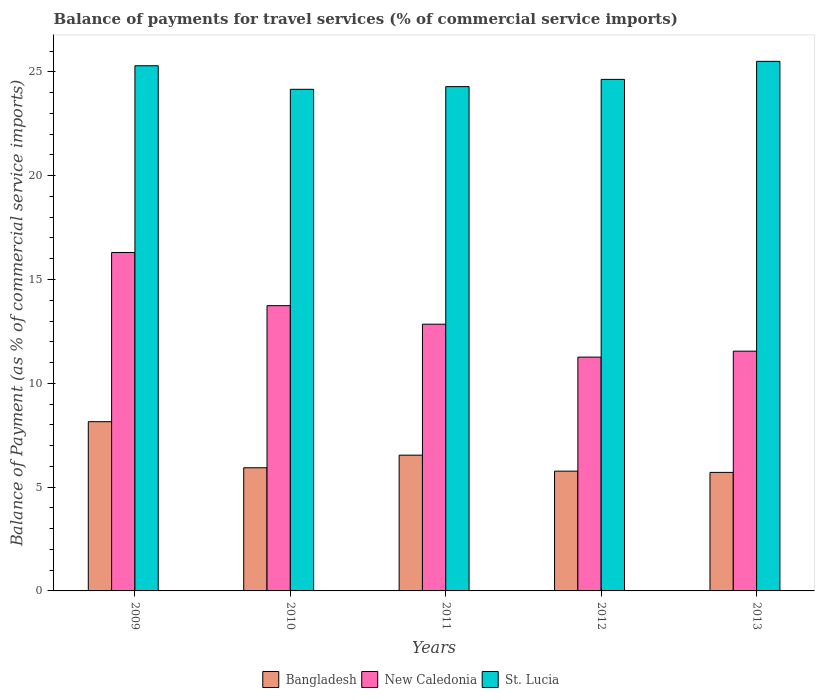Are the number of bars per tick equal to the number of legend labels?
Make the answer very short. Yes. Are the number of bars on each tick of the X-axis equal?
Provide a short and direct response. Yes. How many bars are there on the 4th tick from the right?
Provide a short and direct response. 3. What is the label of the 3rd group of bars from the left?
Provide a succinct answer. 2011. In how many cases, is the number of bars for a given year not equal to the number of legend labels?
Ensure brevity in your answer.  0. What is the balance of payments for travel services in St. Lucia in 2012?
Provide a short and direct response. 24.64. Across all years, what is the maximum balance of payments for travel services in New Caledonia?
Offer a very short reply. 16.3. Across all years, what is the minimum balance of payments for travel services in Bangladesh?
Provide a succinct answer. 5.71. In which year was the balance of payments for travel services in St. Lucia minimum?
Provide a succinct answer. 2010. What is the total balance of payments for travel services in New Caledonia in the graph?
Offer a terse response. 65.69. What is the difference between the balance of payments for travel services in New Caledonia in 2012 and that in 2013?
Keep it short and to the point. -0.29. What is the difference between the balance of payments for travel services in St. Lucia in 2011 and the balance of payments for travel services in New Caledonia in 2010?
Your response must be concise. 10.55. What is the average balance of payments for travel services in New Caledonia per year?
Give a very brief answer. 13.14. In the year 2012, what is the difference between the balance of payments for travel services in St. Lucia and balance of payments for travel services in Bangladesh?
Give a very brief answer. 18.87. What is the ratio of the balance of payments for travel services in New Caledonia in 2009 to that in 2012?
Keep it short and to the point. 1.45. What is the difference between the highest and the second highest balance of payments for travel services in New Caledonia?
Your answer should be very brief. 2.56. What is the difference between the highest and the lowest balance of payments for travel services in St. Lucia?
Provide a succinct answer. 1.35. In how many years, is the balance of payments for travel services in St. Lucia greater than the average balance of payments for travel services in St. Lucia taken over all years?
Your response must be concise. 2. Is the sum of the balance of payments for travel services in New Caledonia in 2010 and 2012 greater than the maximum balance of payments for travel services in Bangladesh across all years?
Provide a short and direct response. Yes. What does the 3rd bar from the left in 2012 represents?
Offer a terse response. St. Lucia. What does the 1st bar from the right in 2010 represents?
Provide a short and direct response. St. Lucia. How many bars are there?
Your answer should be compact. 15. What is the difference between two consecutive major ticks on the Y-axis?
Provide a short and direct response. 5. Are the values on the major ticks of Y-axis written in scientific E-notation?
Your answer should be very brief. No. Does the graph contain any zero values?
Provide a succinct answer. No. Does the graph contain grids?
Offer a terse response. No. How many legend labels are there?
Offer a very short reply. 3. How are the legend labels stacked?
Provide a short and direct response. Horizontal. What is the title of the graph?
Keep it short and to the point. Balance of payments for travel services (% of commercial service imports). What is the label or title of the X-axis?
Offer a terse response. Years. What is the label or title of the Y-axis?
Keep it short and to the point. Balance of Payment (as % of commercial service imports). What is the Balance of Payment (as % of commercial service imports) in Bangladesh in 2009?
Your answer should be very brief. 8.15. What is the Balance of Payment (as % of commercial service imports) in New Caledonia in 2009?
Your response must be concise. 16.3. What is the Balance of Payment (as % of commercial service imports) of St. Lucia in 2009?
Your response must be concise. 25.29. What is the Balance of Payment (as % of commercial service imports) of Bangladesh in 2010?
Provide a succinct answer. 5.93. What is the Balance of Payment (as % of commercial service imports) in New Caledonia in 2010?
Give a very brief answer. 13.74. What is the Balance of Payment (as % of commercial service imports) in St. Lucia in 2010?
Your answer should be compact. 24.16. What is the Balance of Payment (as % of commercial service imports) of Bangladesh in 2011?
Your response must be concise. 6.54. What is the Balance of Payment (as % of commercial service imports) in New Caledonia in 2011?
Your answer should be very brief. 12.85. What is the Balance of Payment (as % of commercial service imports) in St. Lucia in 2011?
Ensure brevity in your answer.  24.29. What is the Balance of Payment (as % of commercial service imports) of Bangladesh in 2012?
Give a very brief answer. 5.77. What is the Balance of Payment (as % of commercial service imports) of New Caledonia in 2012?
Provide a short and direct response. 11.26. What is the Balance of Payment (as % of commercial service imports) of St. Lucia in 2012?
Provide a succinct answer. 24.64. What is the Balance of Payment (as % of commercial service imports) in Bangladesh in 2013?
Ensure brevity in your answer.  5.71. What is the Balance of Payment (as % of commercial service imports) of New Caledonia in 2013?
Your answer should be very brief. 11.55. What is the Balance of Payment (as % of commercial service imports) in St. Lucia in 2013?
Provide a short and direct response. 25.51. Across all years, what is the maximum Balance of Payment (as % of commercial service imports) of Bangladesh?
Offer a terse response. 8.15. Across all years, what is the maximum Balance of Payment (as % of commercial service imports) in New Caledonia?
Your answer should be very brief. 16.3. Across all years, what is the maximum Balance of Payment (as % of commercial service imports) of St. Lucia?
Make the answer very short. 25.51. Across all years, what is the minimum Balance of Payment (as % of commercial service imports) of Bangladesh?
Your answer should be very brief. 5.71. Across all years, what is the minimum Balance of Payment (as % of commercial service imports) of New Caledonia?
Make the answer very short. 11.26. Across all years, what is the minimum Balance of Payment (as % of commercial service imports) in St. Lucia?
Ensure brevity in your answer.  24.16. What is the total Balance of Payment (as % of commercial service imports) of Bangladesh in the graph?
Give a very brief answer. 32.1. What is the total Balance of Payment (as % of commercial service imports) in New Caledonia in the graph?
Your answer should be very brief. 65.69. What is the total Balance of Payment (as % of commercial service imports) in St. Lucia in the graph?
Your answer should be compact. 123.89. What is the difference between the Balance of Payment (as % of commercial service imports) of Bangladesh in 2009 and that in 2010?
Offer a terse response. 2.22. What is the difference between the Balance of Payment (as % of commercial service imports) of New Caledonia in 2009 and that in 2010?
Make the answer very short. 2.56. What is the difference between the Balance of Payment (as % of commercial service imports) of St. Lucia in 2009 and that in 2010?
Offer a terse response. 1.14. What is the difference between the Balance of Payment (as % of commercial service imports) of Bangladesh in 2009 and that in 2011?
Give a very brief answer. 1.61. What is the difference between the Balance of Payment (as % of commercial service imports) of New Caledonia in 2009 and that in 2011?
Keep it short and to the point. 3.45. What is the difference between the Balance of Payment (as % of commercial service imports) of Bangladesh in 2009 and that in 2012?
Your response must be concise. 2.38. What is the difference between the Balance of Payment (as % of commercial service imports) of New Caledonia in 2009 and that in 2012?
Offer a very short reply. 5.04. What is the difference between the Balance of Payment (as % of commercial service imports) of St. Lucia in 2009 and that in 2012?
Offer a very short reply. 0.66. What is the difference between the Balance of Payment (as % of commercial service imports) in Bangladesh in 2009 and that in 2013?
Offer a very short reply. 2.44. What is the difference between the Balance of Payment (as % of commercial service imports) of New Caledonia in 2009 and that in 2013?
Make the answer very short. 4.75. What is the difference between the Balance of Payment (as % of commercial service imports) of St. Lucia in 2009 and that in 2013?
Give a very brief answer. -0.21. What is the difference between the Balance of Payment (as % of commercial service imports) of Bangladesh in 2010 and that in 2011?
Provide a short and direct response. -0.61. What is the difference between the Balance of Payment (as % of commercial service imports) in New Caledonia in 2010 and that in 2011?
Your answer should be compact. 0.89. What is the difference between the Balance of Payment (as % of commercial service imports) in St. Lucia in 2010 and that in 2011?
Your answer should be compact. -0.13. What is the difference between the Balance of Payment (as % of commercial service imports) in Bangladesh in 2010 and that in 2012?
Ensure brevity in your answer.  0.16. What is the difference between the Balance of Payment (as % of commercial service imports) of New Caledonia in 2010 and that in 2012?
Give a very brief answer. 2.48. What is the difference between the Balance of Payment (as % of commercial service imports) in St. Lucia in 2010 and that in 2012?
Make the answer very short. -0.48. What is the difference between the Balance of Payment (as % of commercial service imports) of Bangladesh in 2010 and that in 2013?
Give a very brief answer. 0.22. What is the difference between the Balance of Payment (as % of commercial service imports) in New Caledonia in 2010 and that in 2013?
Offer a terse response. 2.19. What is the difference between the Balance of Payment (as % of commercial service imports) of St. Lucia in 2010 and that in 2013?
Offer a terse response. -1.35. What is the difference between the Balance of Payment (as % of commercial service imports) of Bangladesh in 2011 and that in 2012?
Provide a short and direct response. 0.77. What is the difference between the Balance of Payment (as % of commercial service imports) in New Caledonia in 2011 and that in 2012?
Your answer should be very brief. 1.59. What is the difference between the Balance of Payment (as % of commercial service imports) in St. Lucia in 2011 and that in 2012?
Provide a succinct answer. -0.35. What is the difference between the Balance of Payment (as % of commercial service imports) of Bangladesh in 2011 and that in 2013?
Provide a short and direct response. 0.83. What is the difference between the Balance of Payment (as % of commercial service imports) of New Caledonia in 2011 and that in 2013?
Your answer should be very brief. 1.3. What is the difference between the Balance of Payment (as % of commercial service imports) of St. Lucia in 2011 and that in 2013?
Provide a short and direct response. -1.22. What is the difference between the Balance of Payment (as % of commercial service imports) of Bangladesh in 2012 and that in 2013?
Offer a terse response. 0.06. What is the difference between the Balance of Payment (as % of commercial service imports) in New Caledonia in 2012 and that in 2013?
Provide a succinct answer. -0.29. What is the difference between the Balance of Payment (as % of commercial service imports) of St. Lucia in 2012 and that in 2013?
Offer a terse response. -0.87. What is the difference between the Balance of Payment (as % of commercial service imports) in Bangladesh in 2009 and the Balance of Payment (as % of commercial service imports) in New Caledonia in 2010?
Provide a short and direct response. -5.59. What is the difference between the Balance of Payment (as % of commercial service imports) in Bangladesh in 2009 and the Balance of Payment (as % of commercial service imports) in St. Lucia in 2010?
Offer a very short reply. -16.01. What is the difference between the Balance of Payment (as % of commercial service imports) of New Caledonia in 2009 and the Balance of Payment (as % of commercial service imports) of St. Lucia in 2010?
Your answer should be very brief. -7.86. What is the difference between the Balance of Payment (as % of commercial service imports) of Bangladesh in 2009 and the Balance of Payment (as % of commercial service imports) of New Caledonia in 2011?
Your answer should be compact. -4.7. What is the difference between the Balance of Payment (as % of commercial service imports) of Bangladesh in 2009 and the Balance of Payment (as % of commercial service imports) of St. Lucia in 2011?
Give a very brief answer. -16.14. What is the difference between the Balance of Payment (as % of commercial service imports) of New Caledonia in 2009 and the Balance of Payment (as % of commercial service imports) of St. Lucia in 2011?
Your answer should be compact. -7.99. What is the difference between the Balance of Payment (as % of commercial service imports) in Bangladesh in 2009 and the Balance of Payment (as % of commercial service imports) in New Caledonia in 2012?
Keep it short and to the point. -3.11. What is the difference between the Balance of Payment (as % of commercial service imports) of Bangladesh in 2009 and the Balance of Payment (as % of commercial service imports) of St. Lucia in 2012?
Provide a succinct answer. -16.49. What is the difference between the Balance of Payment (as % of commercial service imports) of New Caledonia in 2009 and the Balance of Payment (as % of commercial service imports) of St. Lucia in 2012?
Provide a succinct answer. -8.34. What is the difference between the Balance of Payment (as % of commercial service imports) in Bangladesh in 2009 and the Balance of Payment (as % of commercial service imports) in New Caledonia in 2013?
Give a very brief answer. -3.4. What is the difference between the Balance of Payment (as % of commercial service imports) of Bangladesh in 2009 and the Balance of Payment (as % of commercial service imports) of St. Lucia in 2013?
Offer a very short reply. -17.35. What is the difference between the Balance of Payment (as % of commercial service imports) in New Caledonia in 2009 and the Balance of Payment (as % of commercial service imports) in St. Lucia in 2013?
Your answer should be compact. -9.21. What is the difference between the Balance of Payment (as % of commercial service imports) of Bangladesh in 2010 and the Balance of Payment (as % of commercial service imports) of New Caledonia in 2011?
Offer a very short reply. -6.91. What is the difference between the Balance of Payment (as % of commercial service imports) in Bangladesh in 2010 and the Balance of Payment (as % of commercial service imports) in St. Lucia in 2011?
Offer a very short reply. -18.36. What is the difference between the Balance of Payment (as % of commercial service imports) of New Caledonia in 2010 and the Balance of Payment (as % of commercial service imports) of St. Lucia in 2011?
Your answer should be compact. -10.55. What is the difference between the Balance of Payment (as % of commercial service imports) in Bangladesh in 2010 and the Balance of Payment (as % of commercial service imports) in New Caledonia in 2012?
Your answer should be compact. -5.33. What is the difference between the Balance of Payment (as % of commercial service imports) of Bangladesh in 2010 and the Balance of Payment (as % of commercial service imports) of St. Lucia in 2012?
Your response must be concise. -18.71. What is the difference between the Balance of Payment (as % of commercial service imports) of New Caledonia in 2010 and the Balance of Payment (as % of commercial service imports) of St. Lucia in 2012?
Offer a terse response. -10.9. What is the difference between the Balance of Payment (as % of commercial service imports) in Bangladesh in 2010 and the Balance of Payment (as % of commercial service imports) in New Caledonia in 2013?
Give a very brief answer. -5.62. What is the difference between the Balance of Payment (as % of commercial service imports) of Bangladesh in 2010 and the Balance of Payment (as % of commercial service imports) of St. Lucia in 2013?
Offer a very short reply. -19.57. What is the difference between the Balance of Payment (as % of commercial service imports) of New Caledonia in 2010 and the Balance of Payment (as % of commercial service imports) of St. Lucia in 2013?
Offer a terse response. -11.77. What is the difference between the Balance of Payment (as % of commercial service imports) in Bangladesh in 2011 and the Balance of Payment (as % of commercial service imports) in New Caledonia in 2012?
Your answer should be compact. -4.72. What is the difference between the Balance of Payment (as % of commercial service imports) in Bangladesh in 2011 and the Balance of Payment (as % of commercial service imports) in St. Lucia in 2012?
Your answer should be very brief. -18.1. What is the difference between the Balance of Payment (as % of commercial service imports) in New Caledonia in 2011 and the Balance of Payment (as % of commercial service imports) in St. Lucia in 2012?
Provide a succinct answer. -11.79. What is the difference between the Balance of Payment (as % of commercial service imports) of Bangladesh in 2011 and the Balance of Payment (as % of commercial service imports) of New Caledonia in 2013?
Your response must be concise. -5.01. What is the difference between the Balance of Payment (as % of commercial service imports) of Bangladesh in 2011 and the Balance of Payment (as % of commercial service imports) of St. Lucia in 2013?
Offer a terse response. -18.97. What is the difference between the Balance of Payment (as % of commercial service imports) of New Caledonia in 2011 and the Balance of Payment (as % of commercial service imports) of St. Lucia in 2013?
Provide a short and direct response. -12.66. What is the difference between the Balance of Payment (as % of commercial service imports) in Bangladesh in 2012 and the Balance of Payment (as % of commercial service imports) in New Caledonia in 2013?
Make the answer very short. -5.78. What is the difference between the Balance of Payment (as % of commercial service imports) in Bangladesh in 2012 and the Balance of Payment (as % of commercial service imports) in St. Lucia in 2013?
Provide a succinct answer. -19.74. What is the difference between the Balance of Payment (as % of commercial service imports) of New Caledonia in 2012 and the Balance of Payment (as % of commercial service imports) of St. Lucia in 2013?
Provide a short and direct response. -14.24. What is the average Balance of Payment (as % of commercial service imports) in Bangladesh per year?
Ensure brevity in your answer.  6.42. What is the average Balance of Payment (as % of commercial service imports) in New Caledonia per year?
Provide a short and direct response. 13.14. What is the average Balance of Payment (as % of commercial service imports) of St. Lucia per year?
Provide a succinct answer. 24.78. In the year 2009, what is the difference between the Balance of Payment (as % of commercial service imports) in Bangladesh and Balance of Payment (as % of commercial service imports) in New Caledonia?
Make the answer very short. -8.15. In the year 2009, what is the difference between the Balance of Payment (as % of commercial service imports) of Bangladesh and Balance of Payment (as % of commercial service imports) of St. Lucia?
Keep it short and to the point. -17.14. In the year 2009, what is the difference between the Balance of Payment (as % of commercial service imports) of New Caledonia and Balance of Payment (as % of commercial service imports) of St. Lucia?
Offer a terse response. -8.99. In the year 2010, what is the difference between the Balance of Payment (as % of commercial service imports) of Bangladesh and Balance of Payment (as % of commercial service imports) of New Caledonia?
Your answer should be very brief. -7.81. In the year 2010, what is the difference between the Balance of Payment (as % of commercial service imports) in Bangladesh and Balance of Payment (as % of commercial service imports) in St. Lucia?
Offer a terse response. -18.23. In the year 2010, what is the difference between the Balance of Payment (as % of commercial service imports) in New Caledonia and Balance of Payment (as % of commercial service imports) in St. Lucia?
Ensure brevity in your answer.  -10.42. In the year 2011, what is the difference between the Balance of Payment (as % of commercial service imports) in Bangladesh and Balance of Payment (as % of commercial service imports) in New Caledonia?
Ensure brevity in your answer.  -6.31. In the year 2011, what is the difference between the Balance of Payment (as % of commercial service imports) of Bangladesh and Balance of Payment (as % of commercial service imports) of St. Lucia?
Ensure brevity in your answer.  -17.75. In the year 2011, what is the difference between the Balance of Payment (as % of commercial service imports) of New Caledonia and Balance of Payment (as % of commercial service imports) of St. Lucia?
Provide a succinct answer. -11.44. In the year 2012, what is the difference between the Balance of Payment (as % of commercial service imports) of Bangladesh and Balance of Payment (as % of commercial service imports) of New Caledonia?
Give a very brief answer. -5.49. In the year 2012, what is the difference between the Balance of Payment (as % of commercial service imports) of Bangladesh and Balance of Payment (as % of commercial service imports) of St. Lucia?
Offer a very short reply. -18.87. In the year 2012, what is the difference between the Balance of Payment (as % of commercial service imports) in New Caledonia and Balance of Payment (as % of commercial service imports) in St. Lucia?
Offer a terse response. -13.38. In the year 2013, what is the difference between the Balance of Payment (as % of commercial service imports) of Bangladesh and Balance of Payment (as % of commercial service imports) of New Caledonia?
Your response must be concise. -5.84. In the year 2013, what is the difference between the Balance of Payment (as % of commercial service imports) of Bangladesh and Balance of Payment (as % of commercial service imports) of St. Lucia?
Give a very brief answer. -19.8. In the year 2013, what is the difference between the Balance of Payment (as % of commercial service imports) in New Caledonia and Balance of Payment (as % of commercial service imports) in St. Lucia?
Your answer should be very brief. -13.96. What is the ratio of the Balance of Payment (as % of commercial service imports) of Bangladesh in 2009 to that in 2010?
Your answer should be compact. 1.37. What is the ratio of the Balance of Payment (as % of commercial service imports) in New Caledonia in 2009 to that in 2010?
Make the answer very short. 1.19. What is the ratio of the Balance of Payment (as % of commercial service imports) in St. Lucia in 2009 to that in 2010?
Your answer should be compact. 1.05. What is the ratio of the Balance of Payment (as % of commercial service imports) of Bangladesh in 2009 to that in 2011?
Your answer should be very brief. 1.25. What is the ratio of the Balance of Payment (as % of commercial service imports) in New Caledonia in 2009 to that in 2011?
Provide a short and direct response. 1.27. What is the ratio of the Balance of Payment (as % of commercial service imports) in St. Lucia in 2009 to that in 2011?
Keep it short and to the point. 1.04. What is the ratio of the Balance of Payment (as % of commercial service imports) of Bangladesh in 2009 to that in 2012?
Provide a succinct answer. 1.41. What is the ratio of the Balance of Payment (as % of commercial service imports) of New Caledonia in 2009 to that in 2012?
Offer a terse response. 1.45. What is the ratio of the Balance of Payment (as % of commercial service imports) in St. Lucia in 2009 to that in 2012?
Offer a very short reply. 1.03. What is the ratio of the Balance of Payment (as % of commercial service imports) of Bangladesh in 2009 to that in 2013?
Offer a very short reply. 1.43. What is the ratio of the Balance of Payment (as % of commercial service imports) in New Caledonia in 2009 to that in 2013?
Your response must be concise. 1.41. What is the ratio of the Balance of Payment (as % of commercial service imports) in St. Lucia in 2009 to that in 2013?
Ensure brevity in your answer.  0.99. What is the ratio of the Balance of Payment (as % of commercial service imports) in Bangladesh in 2010 to that in 2011?
Provide a short and direct response. 0.91. What is the ratio of the Balance of Payment (as % of commercial service imports) of New Caledonia in 2010 to that in 2011?
Provide a succinct answer. 1.07. What is the ratio of the Balance of Payment (as % of commercial service imports) in Bangladesh in 2010 to that in 2012?
Ensure brevity in your answer.  1.03. What is the ratio of the Balance of Payment (as % of commercial service imports) in New Caledonia in 2010 to that in 2012?
Offer a very short reply. 1.22. What is the ratio of the Balance of Payment (as % of commercial service imports) of St. Lucia in 2010 to that in 2012?
Your answer should be compact. 0.98. What is the ratio of the Balance of Payment (as % of commercial service imports) in Bangladesh in 2010 to that in 2013?
Keep it short and to the point. 1.04. What is the ratio of the Balance of Payment (as % of commercial service imports) of New Caledonia in 2010 to that in 2013?
Your answer should be compact. 1.19. What is the ratio of the Balance of Payment (as % of commercial service imports) in St. Lucia in 2010 to that in 2013?
Keep it short and to the point. 0.95. What is the ratio of the Balance of Payment (as % of commercial service imports) of Bangladesh in 2011 to that in 2012?
Provide a short and direct response. 1.13. What is the ratio of the Balance of Payment (as % of commercial service imports) of New Caledonia in 2011 to that in 2012?
Provide a short and direct response. 1.14. What is the ratio of the Balance of Payment (as % of commercial service imports) of St. Lucia in 2011 to that in 2012?
Your response must be concise. 0.99. What is the ratio of the Balance of Payment (as % of commercial service imports) in Bangladesh in 2011 to that in 2013?
Your response must be concise. 1.15. What is the ratio of the Balance of Payment (as % of commercial service imports) of New Caledonia in 2011 to that in 2013?
Provide a short and direct response. 1.11. What is the ratio of the Balance of Payment (as % of commercial service imports) of St. Lucia in 2011 to that in 2013?
Your answer should be compact. 0.95. What is the ratio of the Balance of Payment (as % of commercial service imports) in Bangladesh in 2012 to that in 2013?
Ensure brevity in your answer.  1.01. What is the ratio of the Balance of Payment (as % of commercial service imports) of New Caledonia in 2012 to that in 2013?
Your answer should be very brief. 0.98. What is the ratio of the Balance of Payment (as % of commercial service imports) of St. Lucia in 2012 to that in 2013?
Keep it short and to the point. 0.97. What is the difference between the highest and the second highest Balance of Payment (as % of commercial service imports) in Bangladesh?
Make the answer very short. 1.61. What is the difference between the highest and the second highest Balance of Payment (as % of commercial service imports) of New Caledonia?
Offer a very short reply. 2.56. What is the difference between the highest and the second highest Balance of Payment (as % of commercial service imports) in St. Lucia?
Keep it short and to the point. 0.21. What is the difference between the highest and the lowest Balance of Payment (as % of commercial service imports) in Bangladesh?
Offer a terse response. 2.44. What is the difference between the highest and the lowest Balance of Payment (as % of commercial service imports) of New Caledonia?
Your answer should be very brief. 5.04. What is the difference between the highest and the lowest Balance of Payment (as % of commercial service imports) in St. Lucia?
Provide a short and direct response. 1.35. 